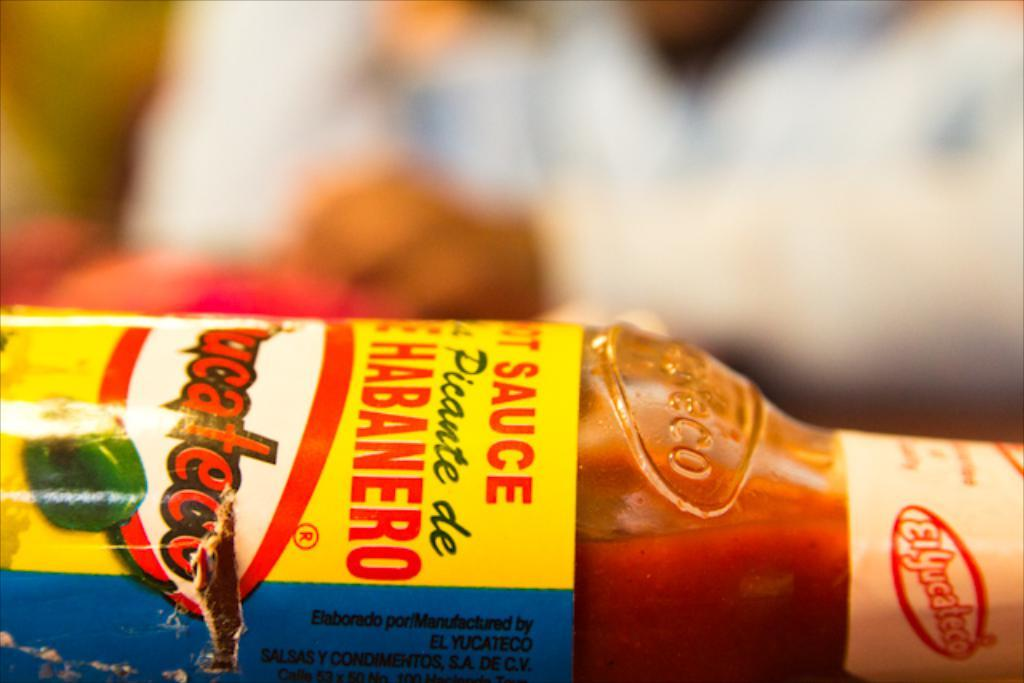<image>
Relay a brief, clear account of the picture shown. A bottle of hot sauce is lying on its side. 